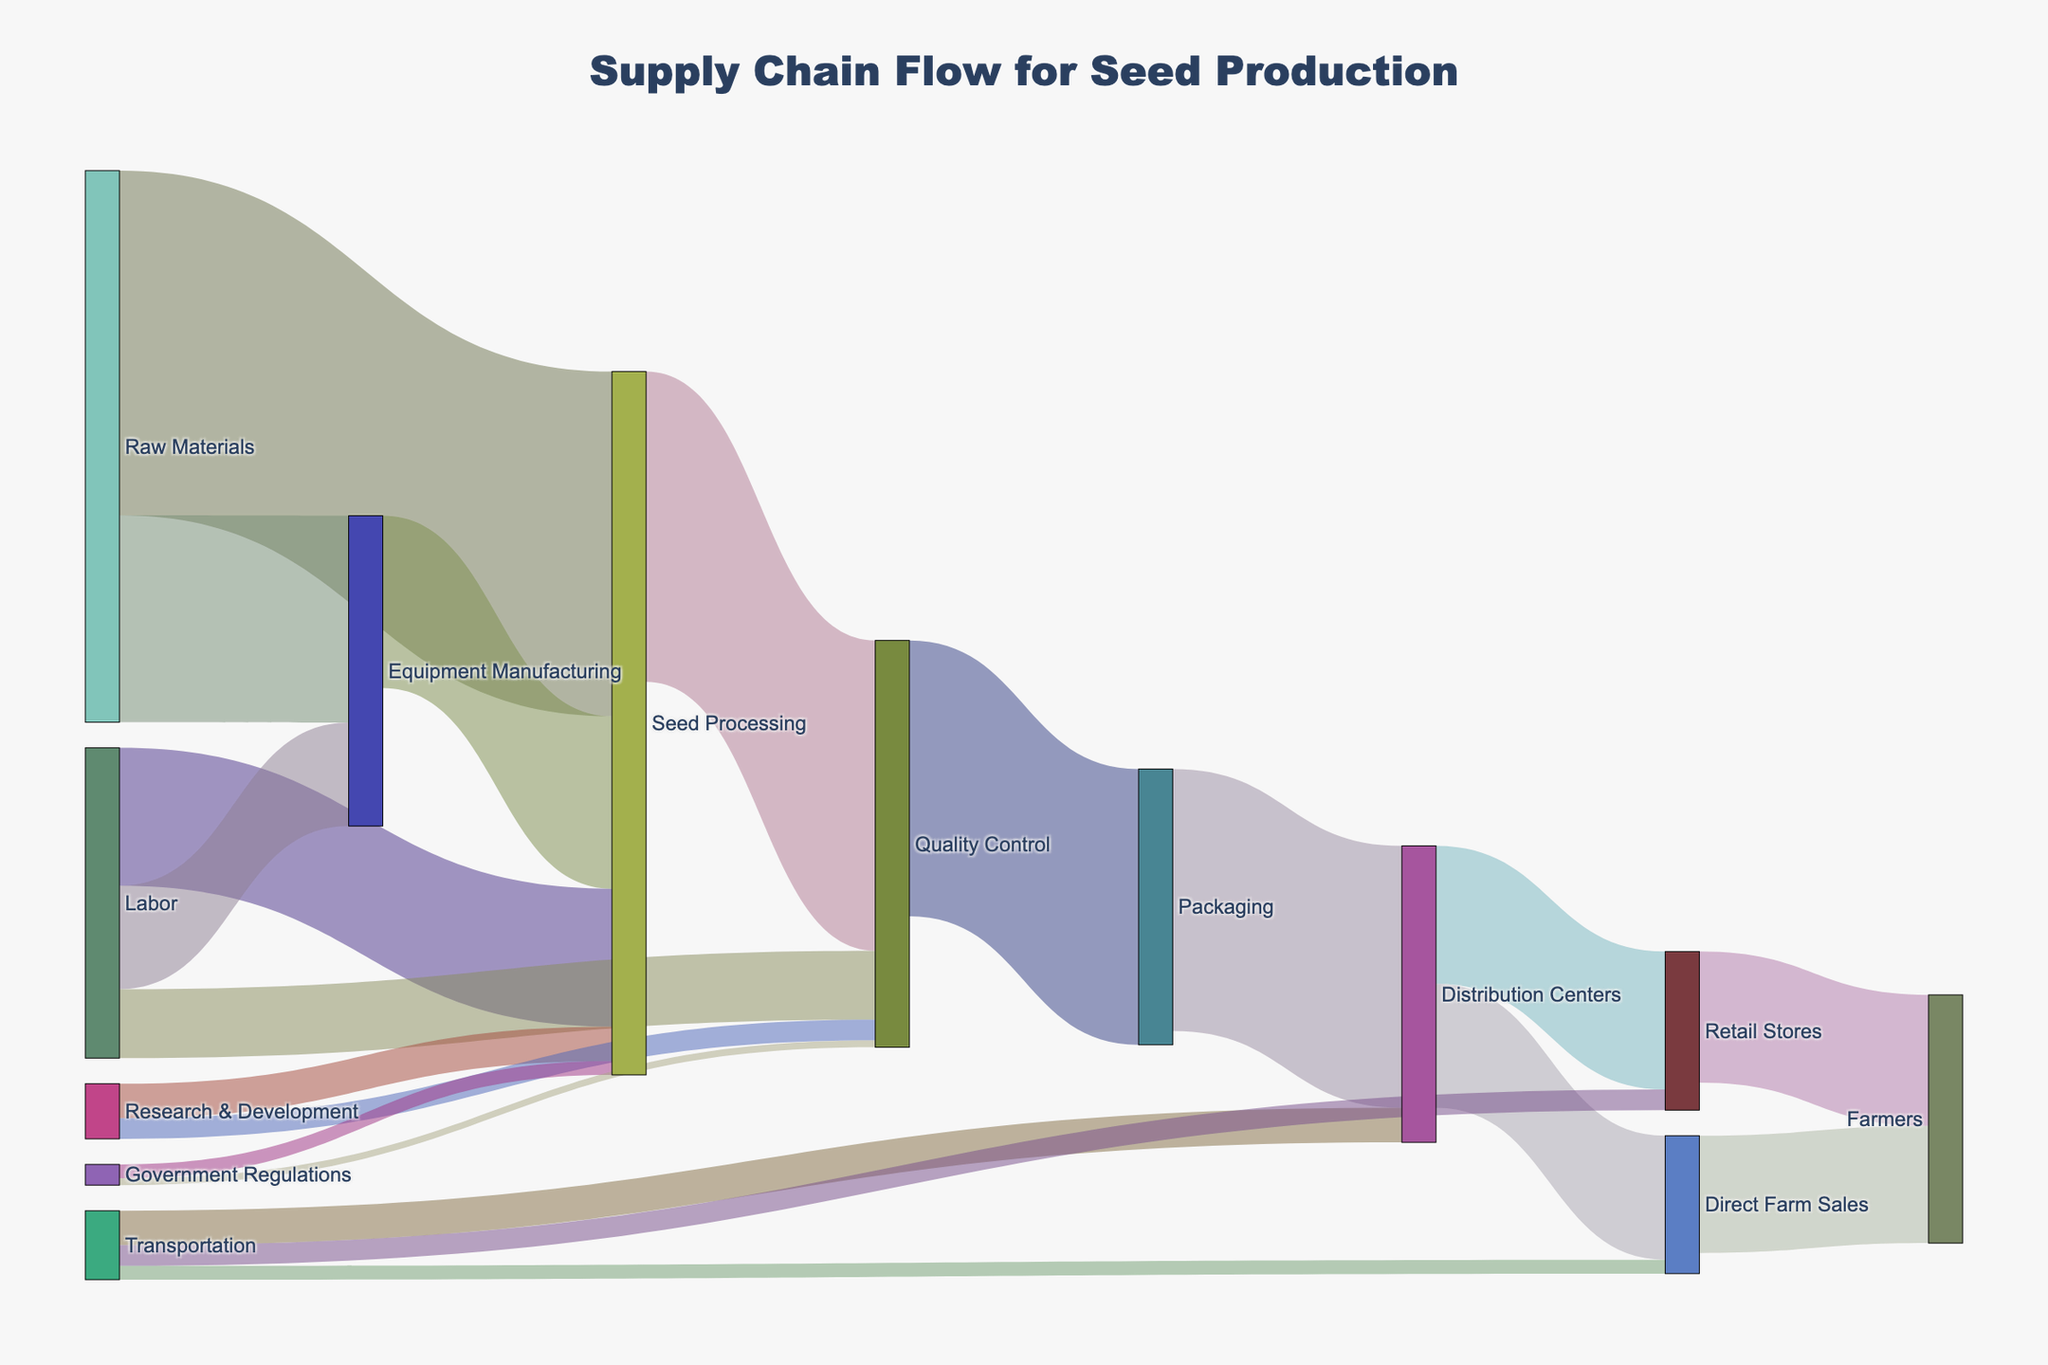What is the initial amount of raw materials going into Seed Processing? The Sankey diagram shows the amount of resources flowing from source to target. The flow from Raw Materials to Seed Processing is indicated to be 5000.
Answer: 5000 How many overall resources are directed to Quality Control? To find the total amount directed to Quality Control, we sum the values flowing into it: Labor (1000), Seed Processing (4500), Research & Development (300), and Government Regulations (100). Therefore, the total is 1000 + 4500 + 300 + 100 = 5900.
Answer: 5900 Which resource flow has the highest value from Seed Processing? According to the Sankey diagram, Seed Processing divides its resources into three flows: Quality Control (4500), Equipment Manufacturing (2500), and government Regulations (200). The highest value is the flow from Seed Processing to Quality Control with a value of 4500.
Answer: 4500 Compare the amount of resources from Distribution Centers going to Retail Stores versus Direct Farm Sales. Which is greater? From the distribution centers, 2000 resources go to Retail Stores and 1800 go to Direct Farm Sales. Comparing these values, the flow to Retail Stores is greater.
Answer: Retail Stores What is the combined total of resources going from Labor to all its targets? Labor directs resources to Seed Processing (2000), Equipment Manufacturing (1500), and Quality Control (1000). Adding these values gives 2000 + 1500 + 1000 = 4500.
Answer: 4500 How much more resources do the Retail Stores receive from Distribution Centers compared to Transportation? Retail Stores receive 2000 resources from Distribution Centers and 300 from Transportation. The difference is 2000 - 300 = 1700.
Answer: 1700 How much total resources are directed towards Distribution Centers? To find the total directed towards Distribution Centers, we sum all the inputs: Packaging (3800) and Transportation (500). Therefore, the total is 3800 + 500 = 4300.
Answer: 4300 Track the flow of resources that start at Research & Development and end at Farmers. What is the total flow amount? Research & Development sends 500 to Seed Processing and 300 to Quality Control. From Seed Processing, 4500 goes to Quality Control. Quality Control then sends 4000 to Packaging, which sends 3800 to Distribution Centers. Distribution Centers then send 2000 to Retail Stores and 1800 to Direct Farm Sales. Finally, Retail Stores send 1900 to Farmers and Direct Farm Sales send 1700 to Farmers. The direct paths are: Research & Development > Seed Processing > Quality Control > Packaging > Distribution Centers > Retail Stores > Farmers = 500 and Research & Development > Quality Control > Packaging > Distribution Centers > Direct Farm Sales > Farmers = 300. Summing up, 500 + 300 = 800.
Answer: 800 Where does the flow from Equipment Manufacturing primarily go? The flow from Equipment Manufacturing primarily goes to Seed Processing, with 2500 units.
Answer: Seed Processing 